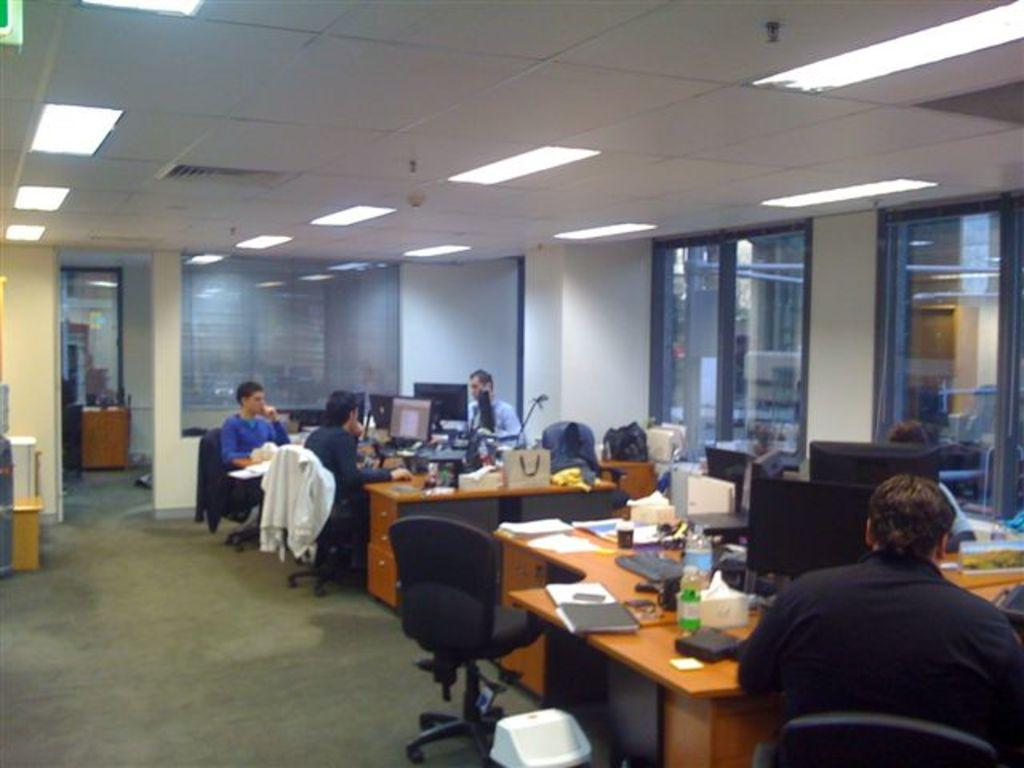What are the people in the image doing? The people in the image are sitting on chairs. What objects are present in the image that the people might be using? There are tables, a laptop, a bag, a bottle, and a file present in the image. Can you describe the seating arrangement in the image? The people are sitting on chairs around tables. What type of hat is the person wearing in the image? There is no hat present in the image. What year is depicted in the image? The image does not depict a specific year; it is a snapshot of a moment in time. Can you explain the magic trick being performed in the image? There is no magic trick being performed in the image; it features people sitting around tables with various objects. 